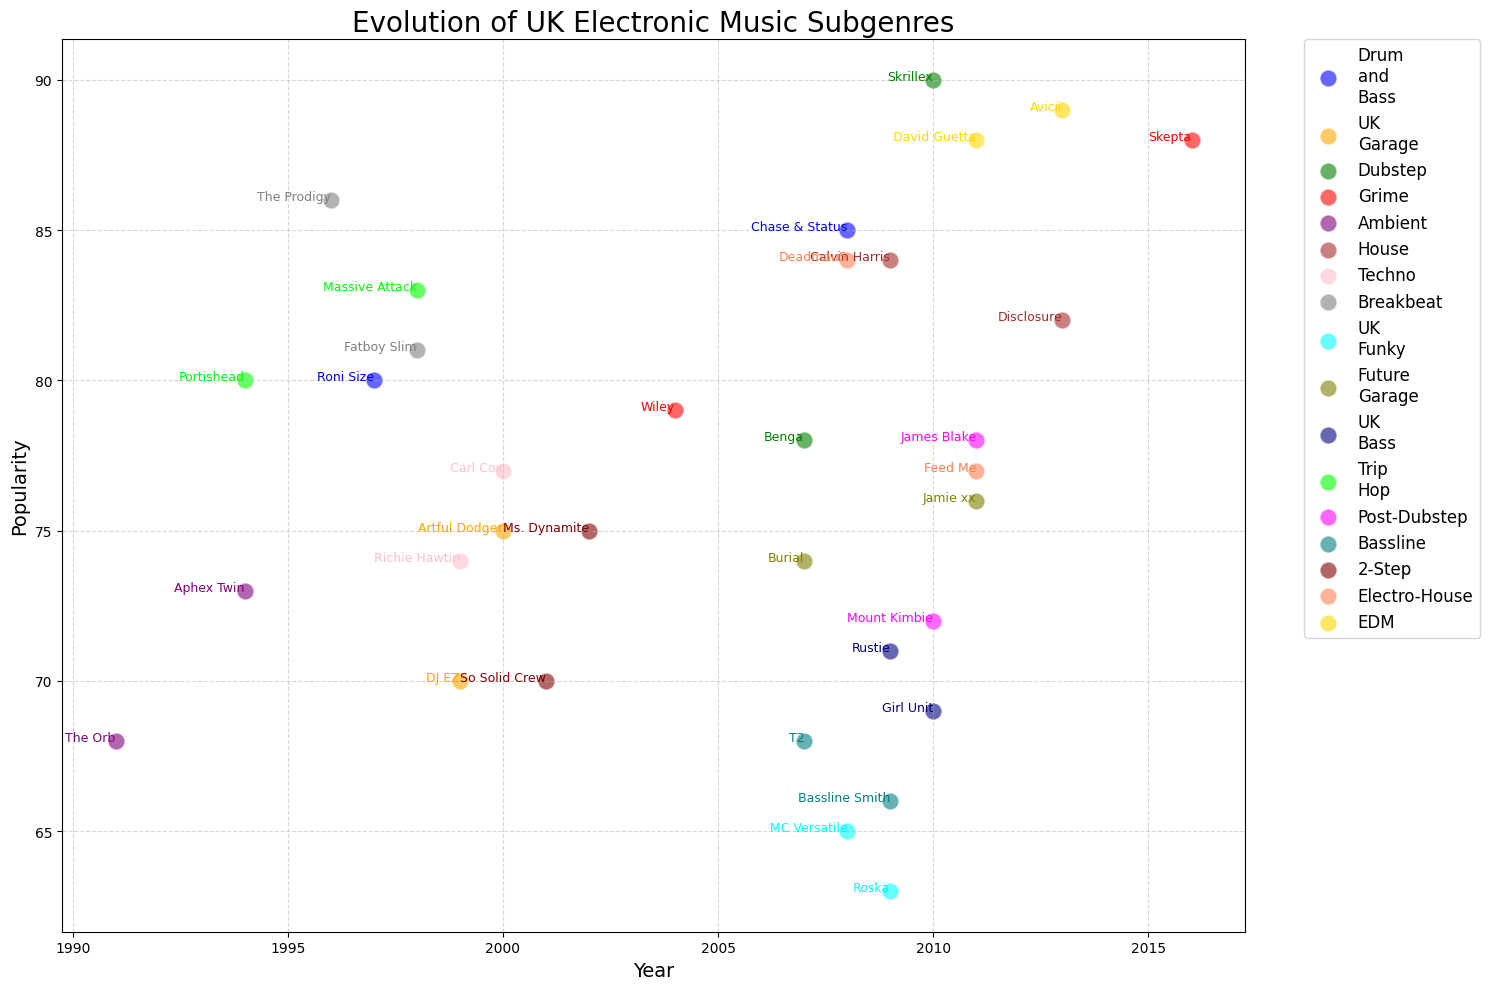Which subgenre shows the earliest appearance of an artist? To determine the earliest appearance, look for the artist with the smallest year value regardless of popularity within each subgenre. The earliest year an artist appears on the plot is 1991.
Answer: Ambient Which artist is the most popular in the Dubstep subgenre? Check the popularity scores of artists within the Dubstep subgenre. Skrillex has a popularity score of 90, while Benga has a score of 78.
Answer: Skrillex Which subgenre has artists with the closest popularity scores? For this, calculate the difference in popularity scores for each pair of artists within each subgenre and find the smallest difference. For post-dubstep, James Blake (78) and Mount Kimbie (72) have a difference of 6, whereas for other subgenres the differences are larger.
Answer: Post-Dubstep What is the average popularity of artists in the House subgenre? Sum the popularity scores of Calvin Harris and Disclosure, then divide by 2: (84 + 82) / 2 = 83.
Answer: 83 Which subgenre has the most artists appearing in the plot? Count the number of unique artists in each subgenre. Every subgenre has exactly 2 artists, so each has the same number.
Answer: All have 2 artists Between 1998 and 2010, which artist has the highest popularity? Identify artists from the years 1998 to 2010 and then compare their popularity scores. Skrillex, from 2010, has a popularity of 90.
Answer: Skrillex Which UK Garage artist first appeared the latest? Compare the years of the appearances of Artful Dodger (2000) and DJ EZ (1999). Artful Dodger appeared in 2000.
Answer: Artful Dodger What year did an artist from the Grime subgenre first appear on the plot? Identify the earliest year among the Grime subgenre artists. Wiley appeared first in 2004.
Answer: 2004 What is the difference in popularity between Deadmau5 and Feed Me? Subtract the popularity score of Feed Me (77) from Deadmau5's popularity score (84): 84 - 77 = 7.
Answer: 7 What color represents the Techno subgenre? Observe the colors assigned to each subgenre in the plot. Techno is represented by the color pink.
Answer: Pink 